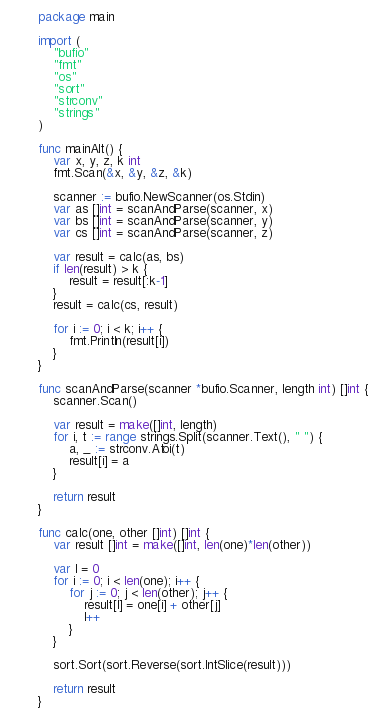<code> <loc_0><loc_0><loc_500><loc_500><_Go_>package main

import (
	"bufio"
	"fmt"
	"os"
	"sort"
	"strconv"
	"strings"
)

func mainAlt() {
	var x, y, z, k int
	fmt.Scan(&x, &y, &z, &k)

	scanner := bufio.NewScanner(os.Stdin)
	var as []int = scanAndParse(scanner, x)
	var bs []int = scanAndParse(scanner, y)
	var cs []int = scanAndParse(scanner, z)

	var result = calc(as, bs)
	if len(result) > k {
		result = result[:k-1]
	}
	result = calc(cs, result)

	for i := 0; i < k; i++ {
		fmt.Println(result[i])
	}
}

func scanAndParse(scanner *bufio.Scanner, length int) []int {
	scanner.Scan()

	var result = make([]int, length)
	for i, t := range strings.Split(scanner.Text(), " ") {
		a, _ := strconv.Atoi(t)
		result[i] = a
	}

	return result
}

func calc(one, other []int) []int {
	var result []int = make([]int, len(one)*len(other))

	var l = 0
	for i := 0; i < len(one); i++ {
		for j := 0; j < len(other); j++ {
			result[l] = one[i] + other[j]
			l++
		}
	}

	sort.Sort(sort.Reverse(sort.IntSlice(result)))

	return result
}
</code> 